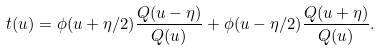Convert formula to latex. <formula><loc_0><loc_0><loc_500><loc_500>t ( u ) = \phi ( u + \eta / 2 ) \frac { Q ( u - \eta ) } { Q ( u ) } + \phi ( u - \eta / 2 ) \frac { Q ( u + \eta ) } { Q ( u ) } .</formula> 